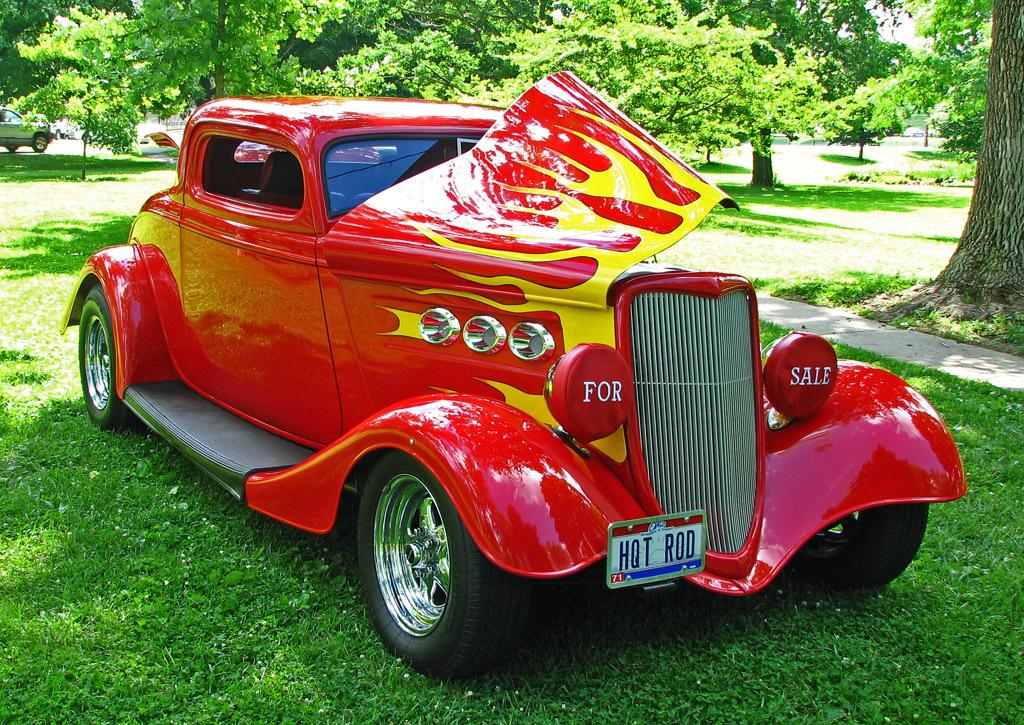What type of vegetation can be seen in the image? There is grass in the image. What else is present in the image besides the grass? There are vehicles with text in the image. What can be seen in the background of the image? There are trees visible in the background of the image. What type of teaching is being conducted in the image? There is no teaching activity present in the image. How does the image depict pollution? The image does not depict pollution; it features grass, vehicles with text, and trees in the background. 